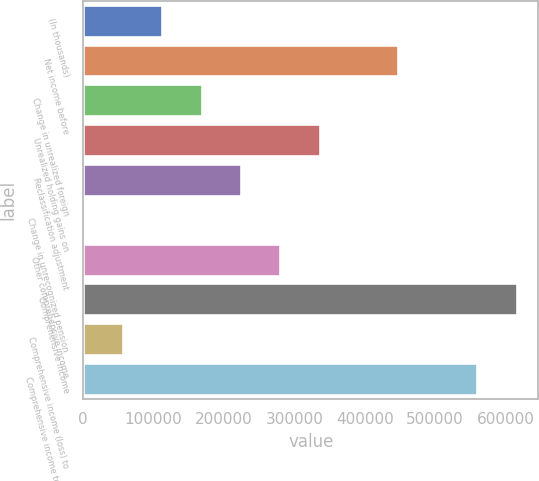Convert chart. <chart><loc_0><loc_0><loc_500><loc_500><bar_chart><fcel>(In thousands)<fcel>Net income before<fcel>Change in unrealized foreign<fcel>Unrealized holding gains on<fcel>Reclassification adjustment<fcel>Change in unrecognized pension<fcel>Other comprehensive income<fcel>Comprehensive income<fcel>Comprehensive income (loss) to<fcel>Comprehensive income to common<nl><fcel>112106<fcel>446684<fcel>168098<fcel>336077<fcel>224091<fcel>120<fcel>280084<fcel>615754<fcel>56112.8<fcel>559761<nl></chart> 